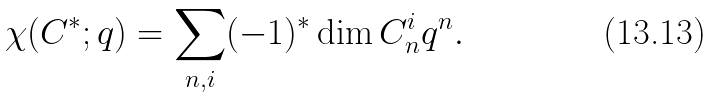Convert formula to latex. <formula><loc_0><loc_0><loc_500><loc_500>\chi ( C ^ { * } ; q ) = \sum _ { n , i } ( - 1 ) ^ { * } \dim C ^ { i } _ { n } q ^ { n } .</formula> 